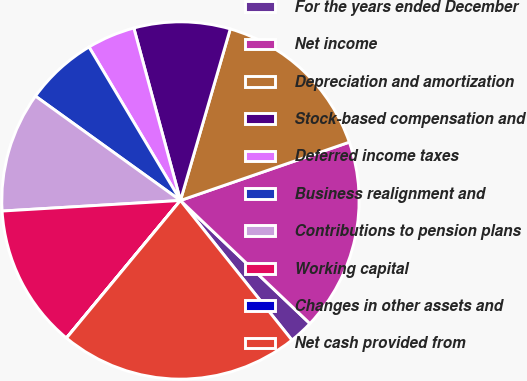<chart> <loc_0><loc_0><loc_500><loc_500><pie_chart><fcel>For the years ended December<fcel>Net income<fcel>Depreciation and amortization<fcel>Stock-based compensation and<fcel>Deferred income taxes<fcel>Business realignment and<fcel>Contributions to pension plans<fcel>Working capital<fcel>Changes in other assets and<fcel>Net cash provided from<nl><fcel>2.18%<fcel>17.39%<fcel>15.21%<fcel>8.7%<fcel>4.35%<fcel>6.52%<fcel>10.87%<fcel>13.04%<fcel>0.01%<fcel>21.73%<nl></chart> 